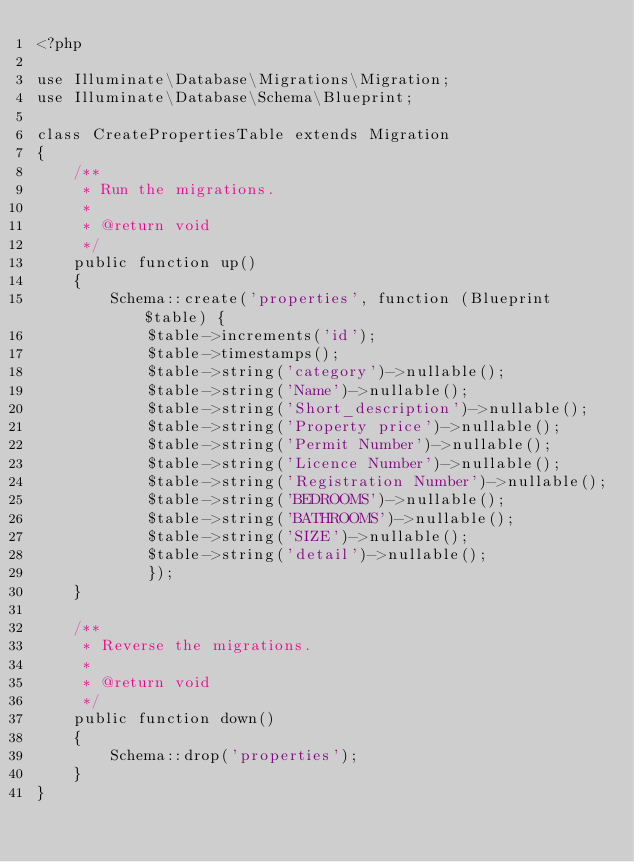Convert code to text. <code><loc_0><loc_0><loc_500><loc_500><_PHP_><?php

use Illuminate\Database\Migrations\Migration;
use Illuminate\Database\Schema\Blueprint;

class CreatePropertiesTable extends Migration
{
    /**
     * Run the migrations.
     *
     * @return void
     */
    public function up()
    {
        Schema::create('properties', function (Blueprint $table) {
            $table->increments('id');
            $table->timestamps();
            $table->string('category')->nullable();
            $table->string('Name')->nullable();
            $table->string('Short_description')->nullable();
            $table->string('Property price')->nullable();
            $table->string('Permit Number')->nullable();
            $table->string('Licence Number')->nullable();
            $table->string('Registration Number')->nullable();
            $table->string('BEDROOMS')->nullable();
            $table->string('BATHROOMS')->nullable();
            $table->string('SIZE')->nullable();
            $table->string('detail')->nullable();
            });
    }

    /**
     * Reverse the migrations.
     *
     * @return void
     */
    public function down()
    {
        Schema::drop('properties');
    }
}
</code> 